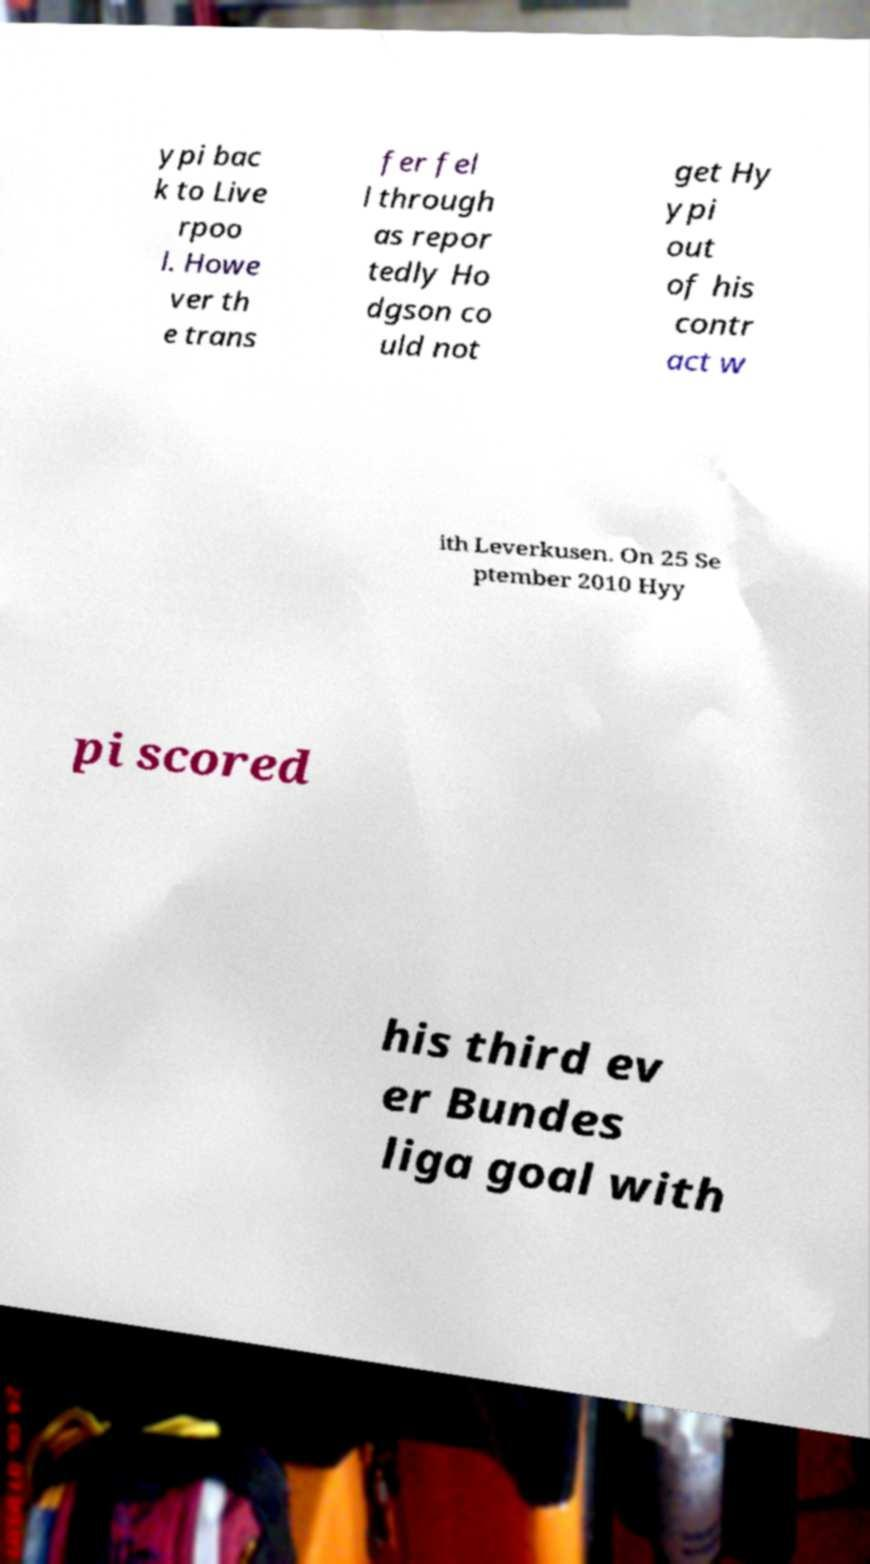Can you read and provide the text displayed in the image?This photo seems to have some interesting text. Can you extract and type it out for me? ypi bac k to Live rpoo l. Howe ver th e trans fer fel l through as repor tedly Ho dgson co uld not get Hy ypi out of his contr act w ith Leverkusen. On 25 Se ptember 2010 Hyy pi scored his third ev er Bundes liga goal with 